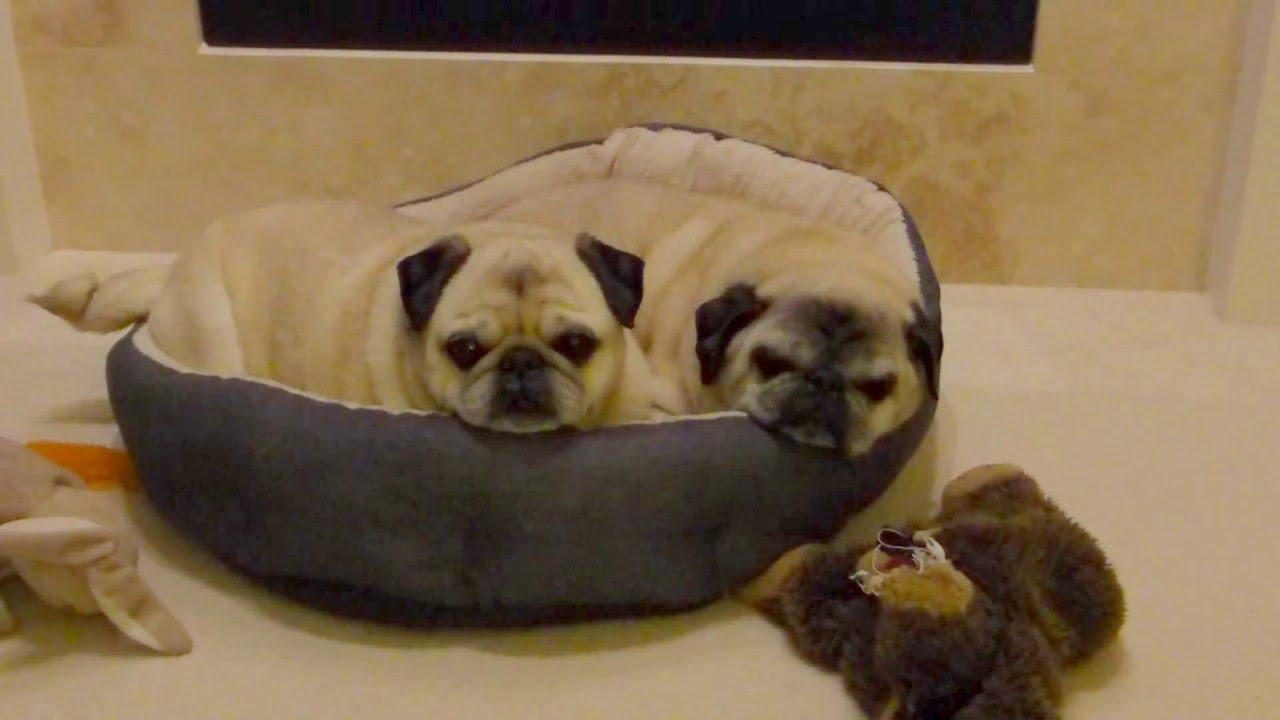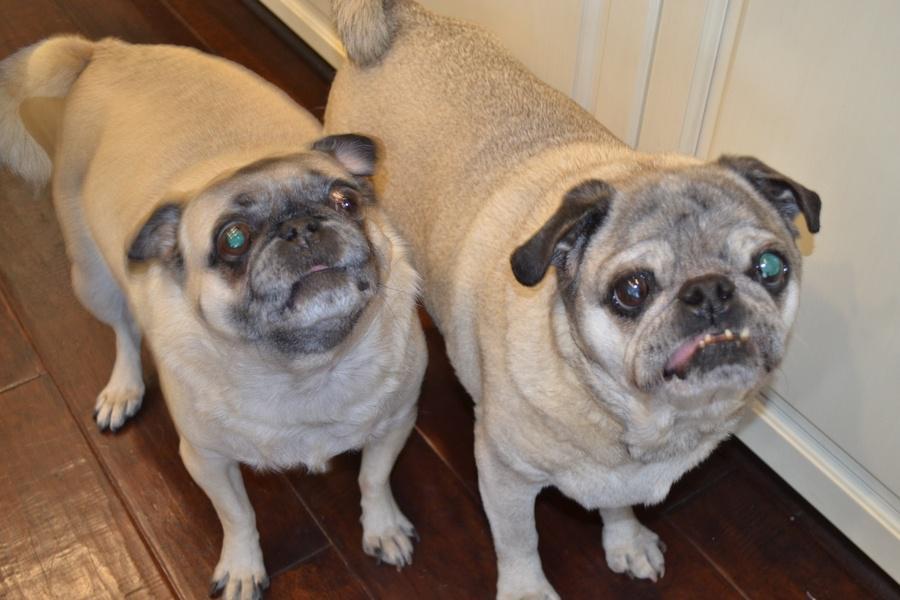The first image is the image on the left, the second image is the image on the right. Evaluate the accuracy of this statement regarding the images: "There is no more than one dog in the left image.". Is it true? Answer yes or no. No. The first image is the image on the left, the second image is the image on the right. Analyze the images presented: Is the assertion "An image shows two pug dogs side-by-side in a roundish container." valid? Answer yes or no. Yes. 